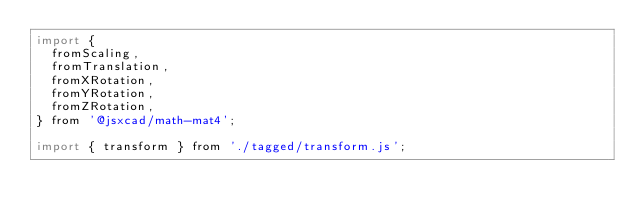<code> <loc_0><loc_0><loc_500><loc_500><_JavaScript_>import {
  fromScaling,
  fromTranslation,
  fromXRotation,
  fromYRotation,
  fromZRotation,
} from '@jsxcad/math-mat4';

import { transform } from './tagged/transform.js';
</code> 